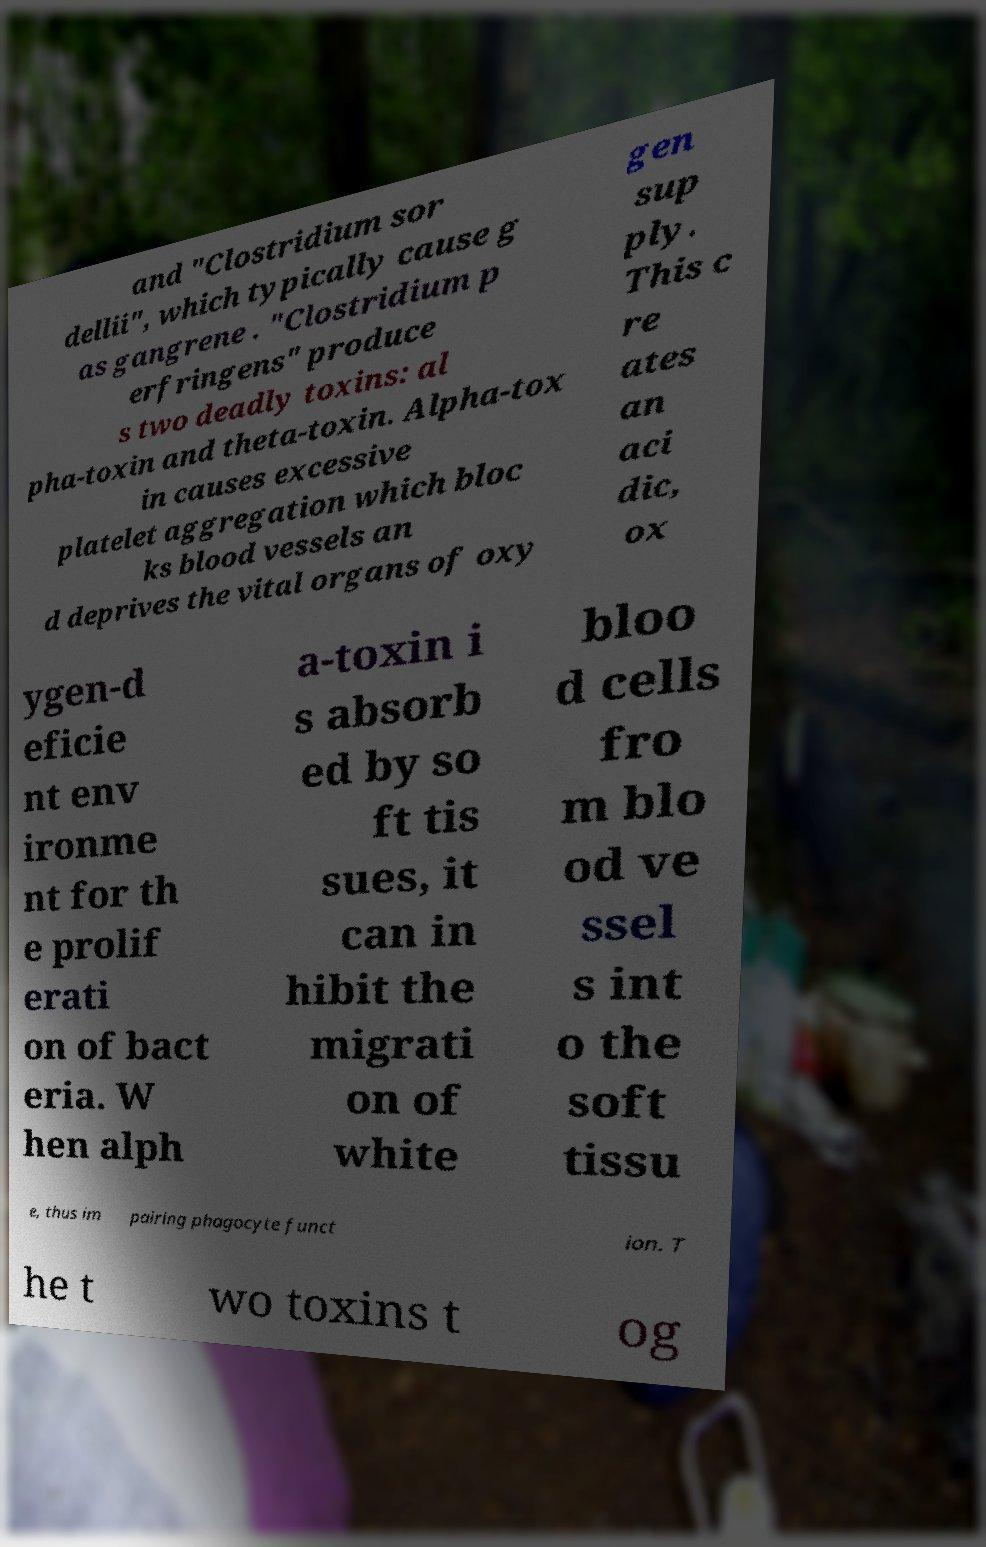Please read and relay the text visible in this image. What does it say? and "Clostridium sor dellii", which typically cause g as gangrene . "Clostridium p erfringens" produce s two deadly toxins: al pha-toxin and theta-toxin. Alpha-tox in causes excessive platelet aggregation which bloc ks blood vessels an d deprives the vital organs of oxy gen sup ply. This c re ates an aci dic, ox ygen-d eficie nt env ironme nt for th e prolif erati on of bact eria. W hen alph a-toxin i s absorb ed by so ft tis sues, it can in hibit the migrati on of white bloo d cells fro m blo od ve ssel s int o the soft tissu e, thus im pairing phagocyte funct ion. T he t wo toxins t og 